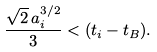Convert formula to latex. <formula><loc_0><loc_0><loc_500><loc_500>\frac { \sqrt { 2 } \, a _ { i } ^ { 3 / 2 } } { 3 } < ( t _ { i } - t _ { B } ) .</formula> 